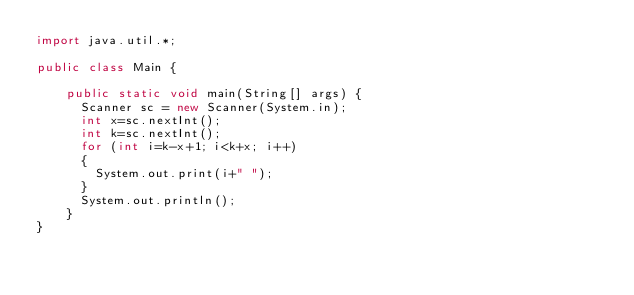Convert code to text. <code><loc_0><loc_0><loc_500><loc_500><_Java_>import java.util.*;
 
public class Main {
 
    public static void main(String[] args) {
      Scanner sc = new Scanner(System.in);
      int x=sc.nextInt();
      int k=sc.nextInt();
      for (int i=k-x+1; i<k+x; i++)
      {
        System.out.print(i+" ");
      }
      System.out.println();
    }
}</code> 